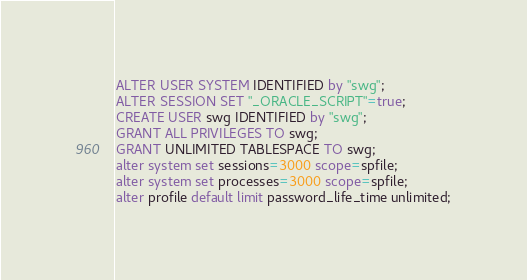Convert code to text. <code><loc_0><loc_0><loc_500><loc_500><_SQL_>ALTER USER SYSTEM IDENTIFIED by "swg";
ALTER SESSION SET "_ORACLE_SCRIPT"=true;
CREATE USER swg IDENTIFIED by "swg";
GRANT ALL PRIVILEGES TO swg;
GRANT UNLIMITED TABLESPACE TO swg;
alter system set sessions=3000 scope=spfile;
alter system set processes=3000 scope=spfile;
alter profile default limit password_life_time unlimited;</code> 